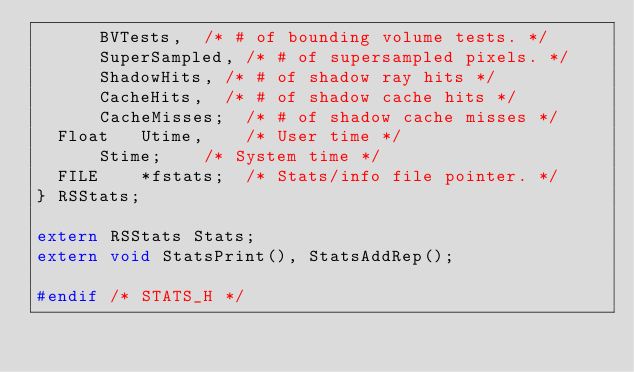<code> <loc_0><loc_0><loc_500><loc_500><_C_>			BVTests,	/* # of bounding volume tests. */
			SuperSampled,	/* # of supersampled pixels. */
			ShadowHits,	/* # of shadow ray hits */
			CacheHits,	/* # of shadow cache hits */
			CacheMisses;	/* # of shadow cache misses */
	Float		Utime,		/* User time */
			Stime;		/* System time */
	FILE		*fstats;	/* Stats/info file pointer. */
} RSStats;

extern RSStats Stats;
extern void StatsPrint(), StatsAddRep();

#endif /* STATS_H */
</code> 